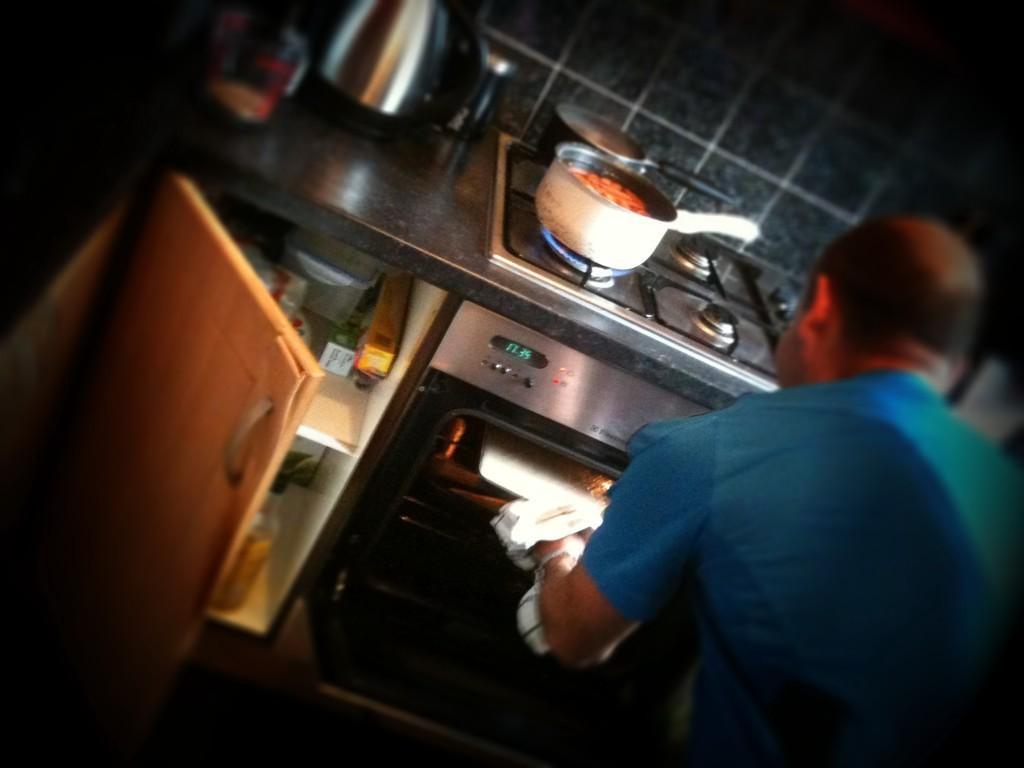Could you give a brief overview of what you see in this image? In the picture there is a kitchen floor and on the stove there are two vessels and beside the stove there are some other objects and under the stove there is an oven and a person is using the oven, on the left side there is a cupboard it is opened and there are some items inside the cupboard, in the background there is a wall. 